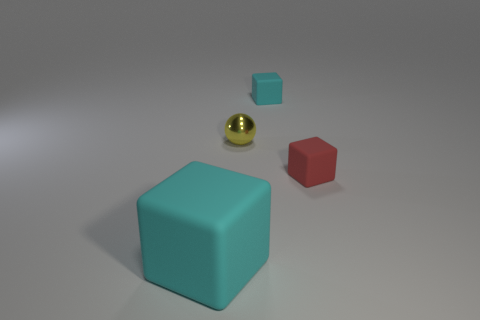Subtract all purple balls. Subtract all cyan cubes. How many balls are left? 1 Add 4 small spheres. How many objects exist? 8 Subtract all balls. How many objects are left? 3 Add 2 cyan blocks. How many cyan blocks are left? 4 Add 3 small metallic objects. How many small metallic objects exist? 4 Subtract 0 brown blocks. How many objects are left? 4 Subtract all small green shiny cylinders. Subtract all tiny cyan rubber blocks. How many objects are left? 3 